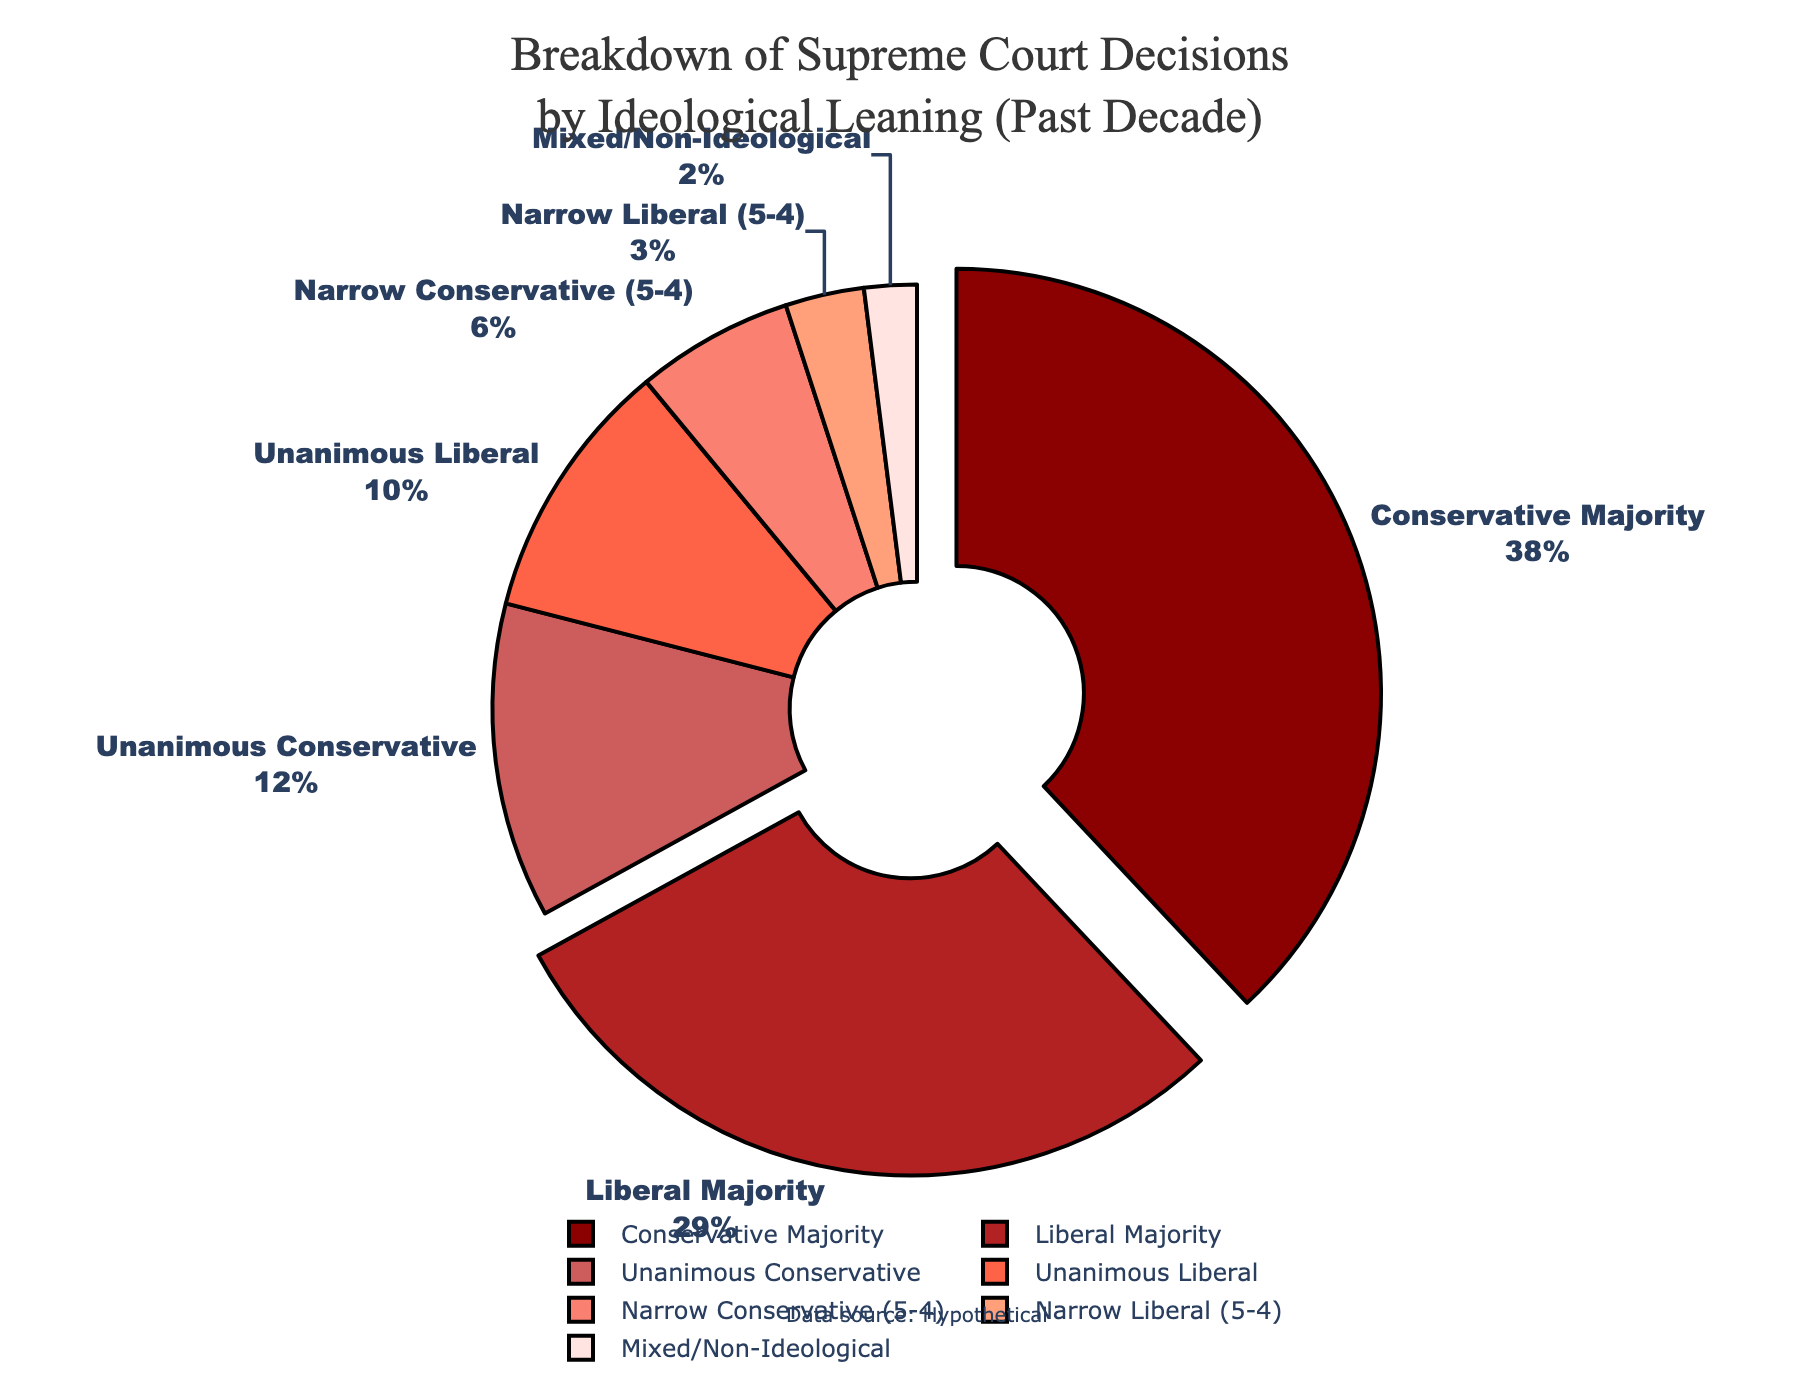What is the percentage of Supreme Court decisions where the majority was conservative? The pie chart shows that the "Conservative Majority" represents 38% of the decisions.
Answer: 38% How many total percentages do unanimous decisions (both conservative and liberal) occupy in the breakdown? Unanimous Conservative decisions are 12% and Unanimous Liberal decisions are 10%. Sum these: 12 + 10 = 22%.
Answer: 22% Which type of decision category has the smallest percentage? By observing the pie chart, the decision category "Mixed/Non-Ideological" has the smallest segment representing 2%.
Answer: Mixed/Non-Ideological Is the percentage of Liberal Majority decisions greater or less than that of the Conservative Majority decisions? The chart indicates a 29% Liberal Majority and a 38% Conservative Majority. Since 29% is less than 38%, the Liberal Majority is less.
Answer: Less How does the percentage of 5-4 narrow decisions compare between conservative and liberal leanings? The pie chart shows "Narrow Conservative (5-4)" at 6% and "Narrow Liberal (5-4)" at 3%. So, "Narrow Conservative (5-4)" decisions are greater.
Answer: Narrow Conservative (5-4) What is the percentage difference between Conservative Majority and Liberal Majority? Conservative Majority is 38%, and Liberal Majority is 29%. The difference is 38% - 29% = 9%.
Answer: 9% What two categories combined make up more than 60% of the decisions? Looking at the largest segments, Conservative Majority (38%) and Liberal Majority (29%) together account for 38 + 29 = 67%, which is more than 60%.
Answer: Conservative Majority and Liberal Majority Identify the color associated with the "Unanimous Conservative" category in the pie chart. The "Unanimous Conservative" segment is visually represented by a particular shade of red (#CD5C5C). The specific color might vary by interpretation, but it is visually distinguishable.
Answer: A shade of red If you sum the percentages of Unanimous Conservative, Unanimous Liberal, and Mixed/Non-Ideological, what is the total? Unanimous Conservative is 12%, Unanimous Liberal is 10%, and Mixed/Non-Ideological is 2%. Their total is 12 + 10 + 2 = 24%.
Answer: 24% Does any ideological category other than Conservative Majority alone occupy more than one-third of the pie chart? Conservative Majority is 38%, more than one-third, while no other single category alone exceeds one-third (33.33%).
Answer: No 